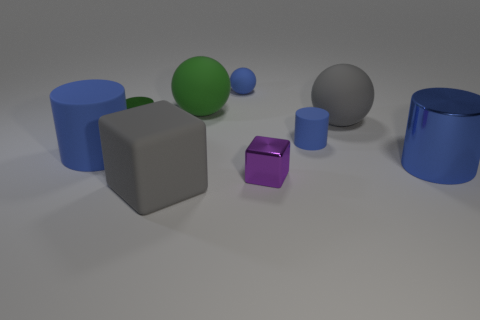Subtract 4 cylinders. How many cylinders are left? 0 Add 6 blue rubber cylinders. How many blue rubber cylinders are left? 8 Add 1 tiny rubber cylinders. How many tiny rubber cylinders exist? 2 Subtract all blue cylinders. How many cylinders are left? 1 Subtract all big rubber spheres. How many spheres are left? 1 Subtract 1 gray balls. How many objects are left? 8 Subtract all balls. How many objects are left? 6 Subtract all cyan cubes. Subtract all gray cylinders. How many cubes are left? 2 Subtract all purple cylinders. How many blue balls are left? 1 Subtract all tiny cyan shiny cylinders. Subtract all tiny blue balls. How many objects are left? 8 